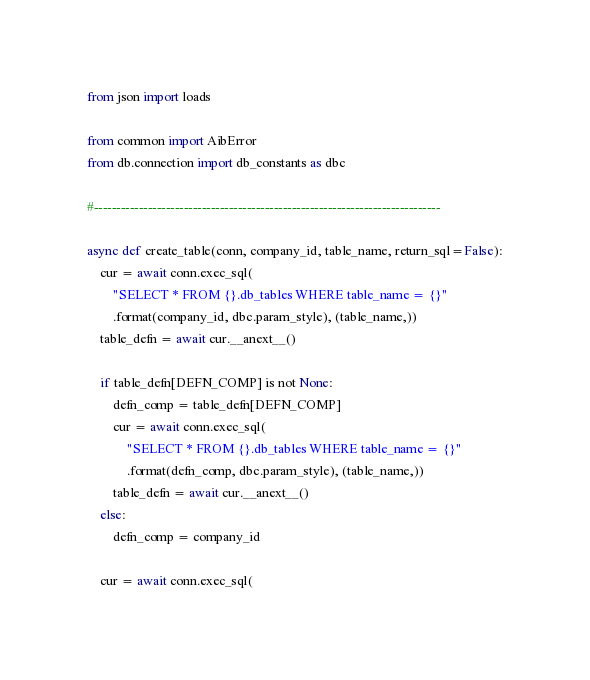<code> <loc_0><loc_0><loc_500><loc_500><_Python_>from json import loads

from common import AibError
from db.connection import db_constants as dbc

#-----------------------------------------------------------------------------

async def create_table(conn, company_id, table_name, return_sql=False):
    cur = await conn.exec_sql(
        "SELECT * FROM {}.db_tables WHERE table_name = {}"
        .format(company_id, dbc.param_style), (table_name,))
    table_defn = await cur.__anext__()

    if table_defn[DEFN_COMP] is not None:
        defn_comp = table_defn[DEFN_COMP]
        cur = await conn.exec_sql(
            "SELECT * FROM {}.db_tables WHERE table_name = {}"
            .format(defn_comp, dbc.param_style), (table_name,))
        table_defn = await cur.__anext__()
    else:
        defn_comp = company_id

    cur = await conn.exec_sql(</code> 